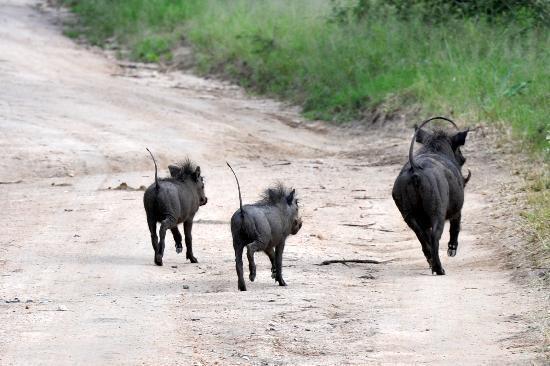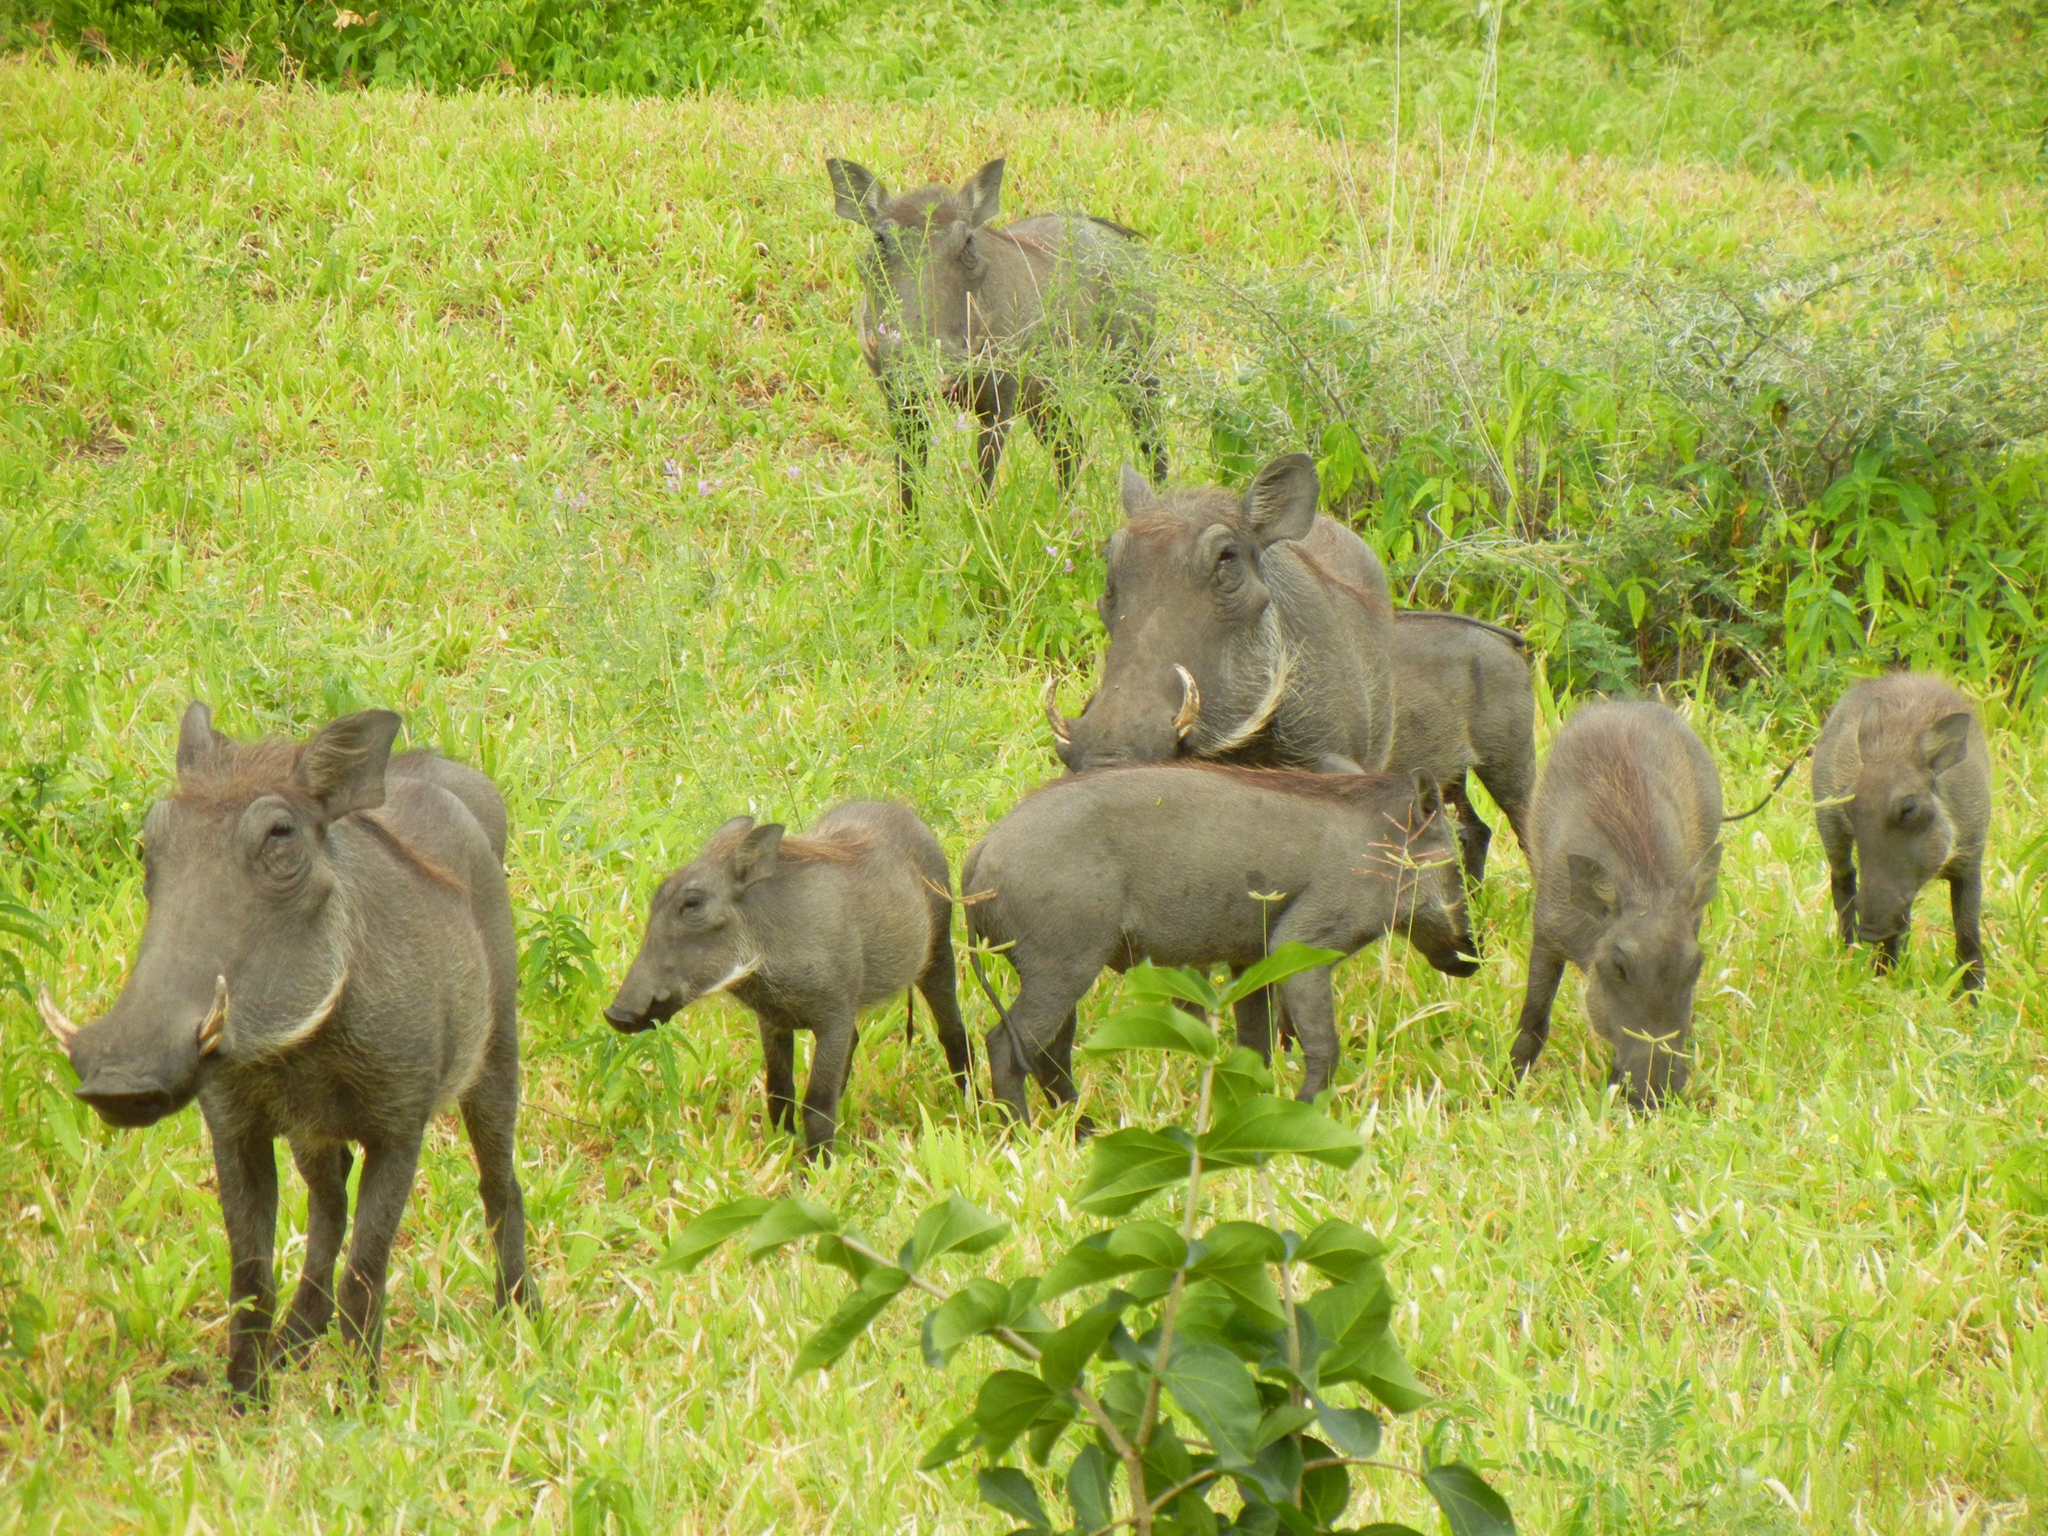The first image is the image on the left, the second image is the image on the right. Considering the images on both sides, is "A mother hog leads a farrow of at least two facing the background." valid? Answer yes or no. Yes. The first image is the image on the left, the second image is the image on the right. Assess this claim about the two images: "At least one image shows animals running away from the camera.". Correct or not? Answer yes or no. Yes. 